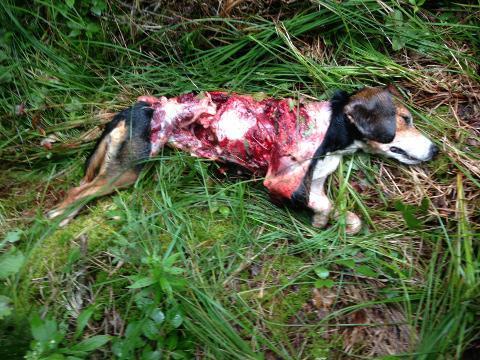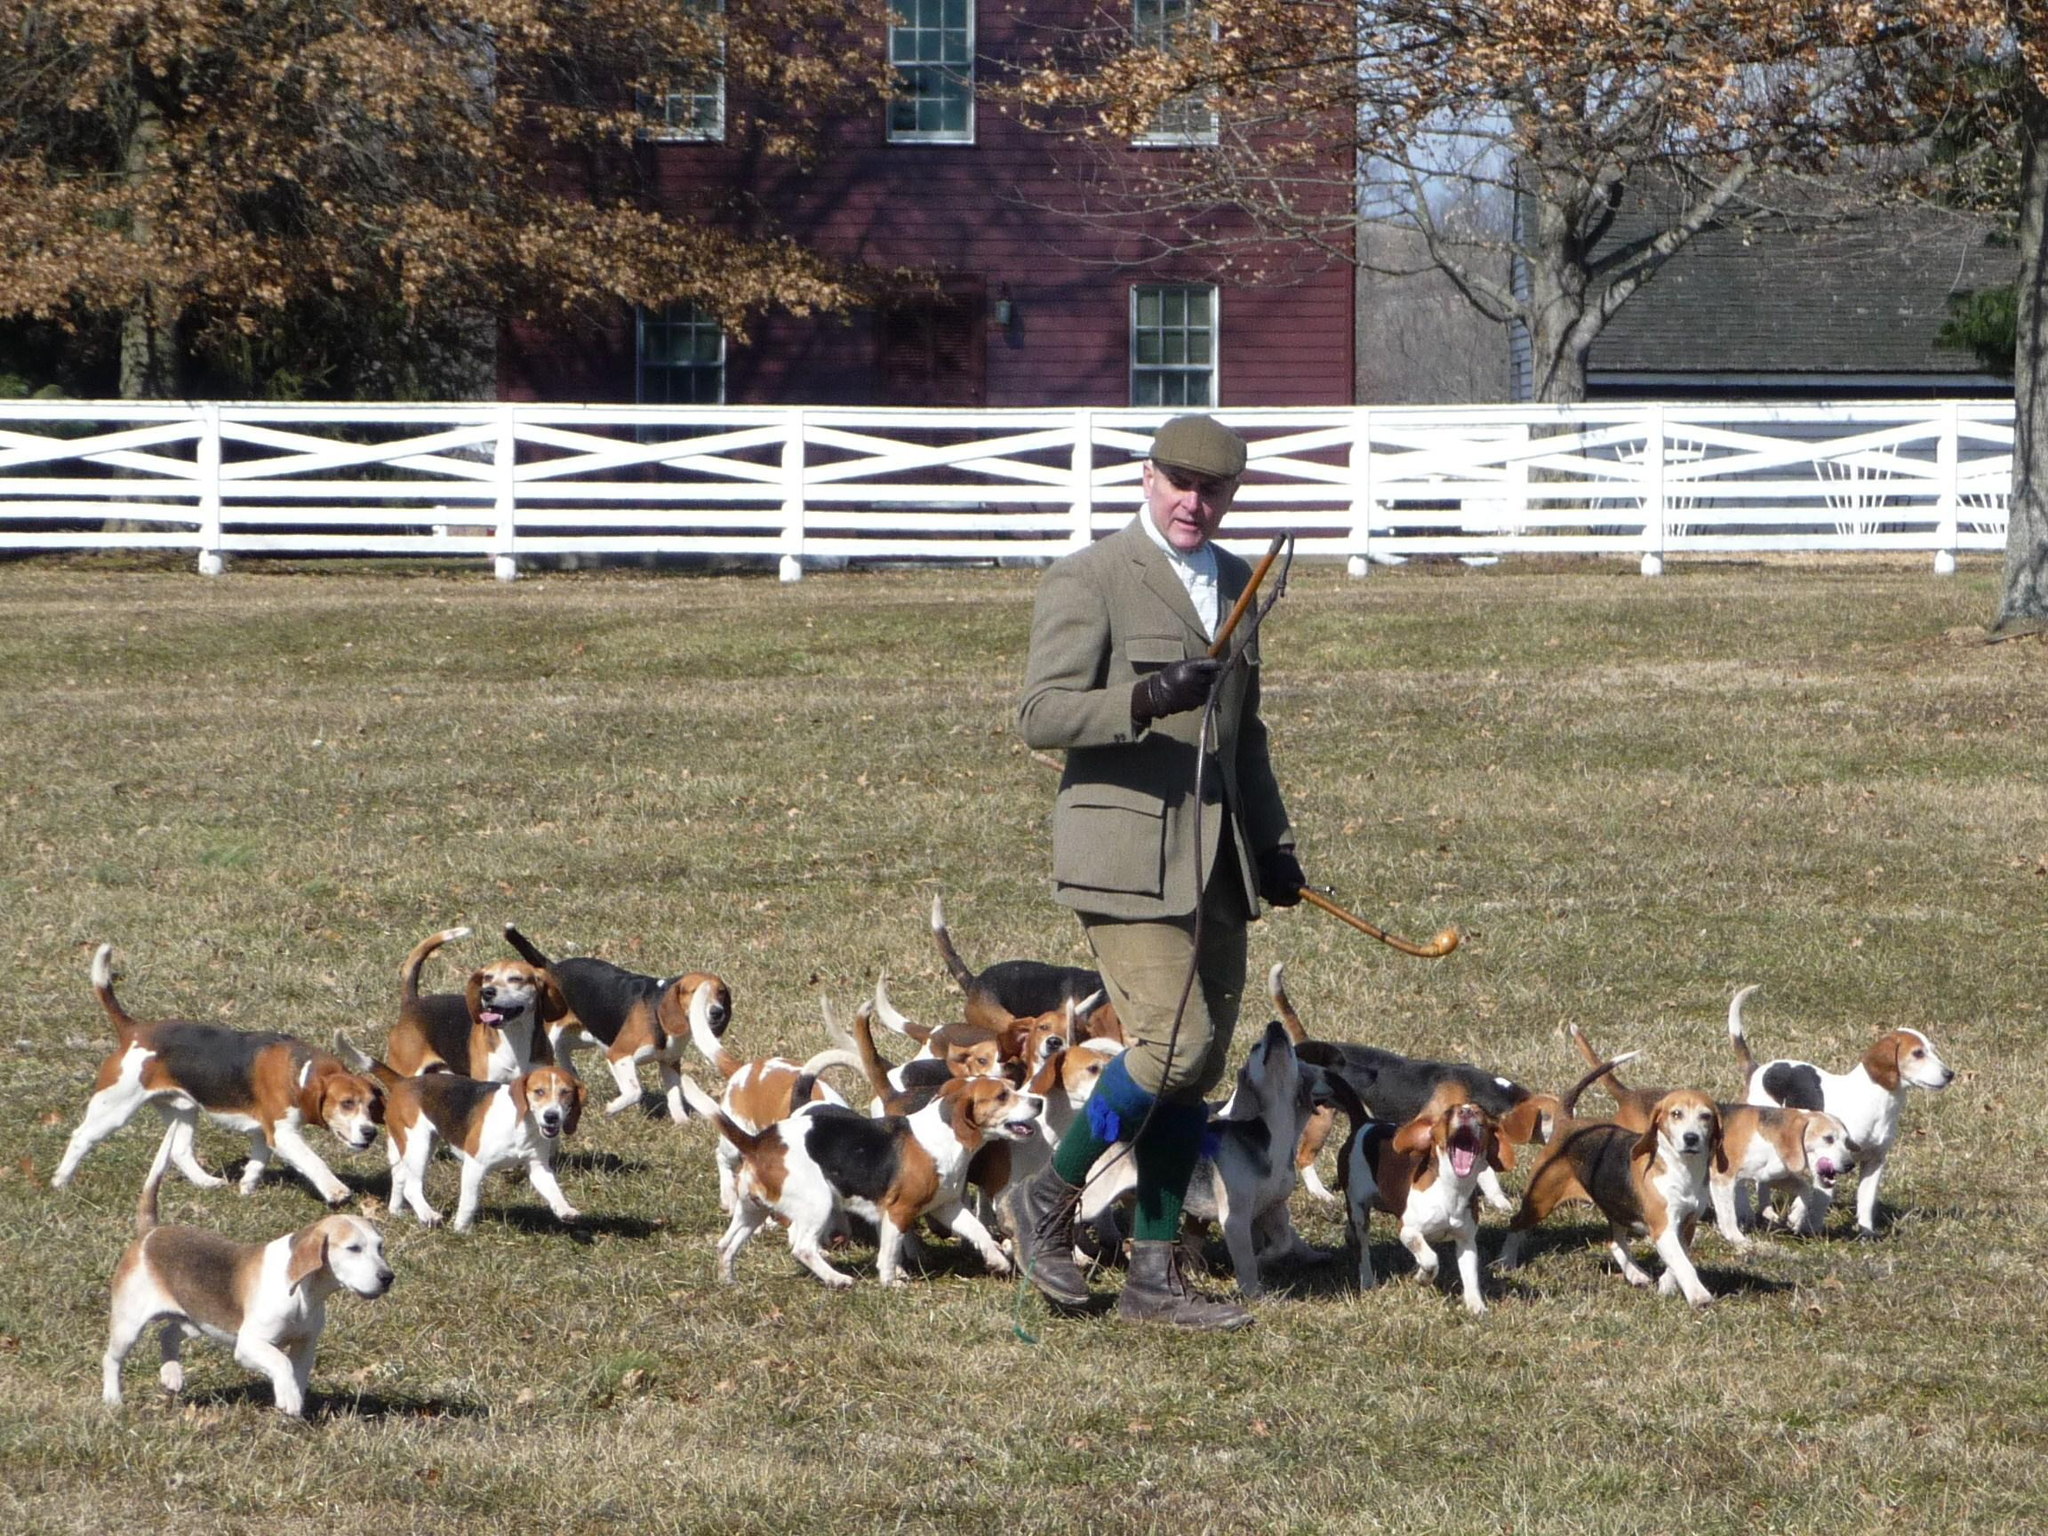The first image is the image on the left, the second image is the image on the right. For the images shown, is this caption "There is a person standing among several dogs in the image on the right." true? Answer yes or no. Yes. The first image is the image on the left, the second image is the image on the right. For the images shown, is this caption "There is one person standing in the image on the right." true? Answer yes or no. Yes. The first image is the image on the left, the second image is the image on the right. Assess this claim about the two images: "Both photos show dogs running in the grass.". Correct or not? Answer yes or no. No. 